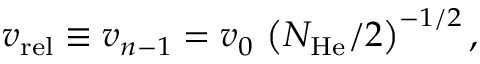Convert formula to latex. <formula><loc_0><loc_0><loc_500><loc_500>v _ { r e l } \equiv v _ { n - 1 } = v _ { 0 } \, \left ( N _ { H e } / 2 \right ) ^ { - 1 / 2 } ,</formula> 